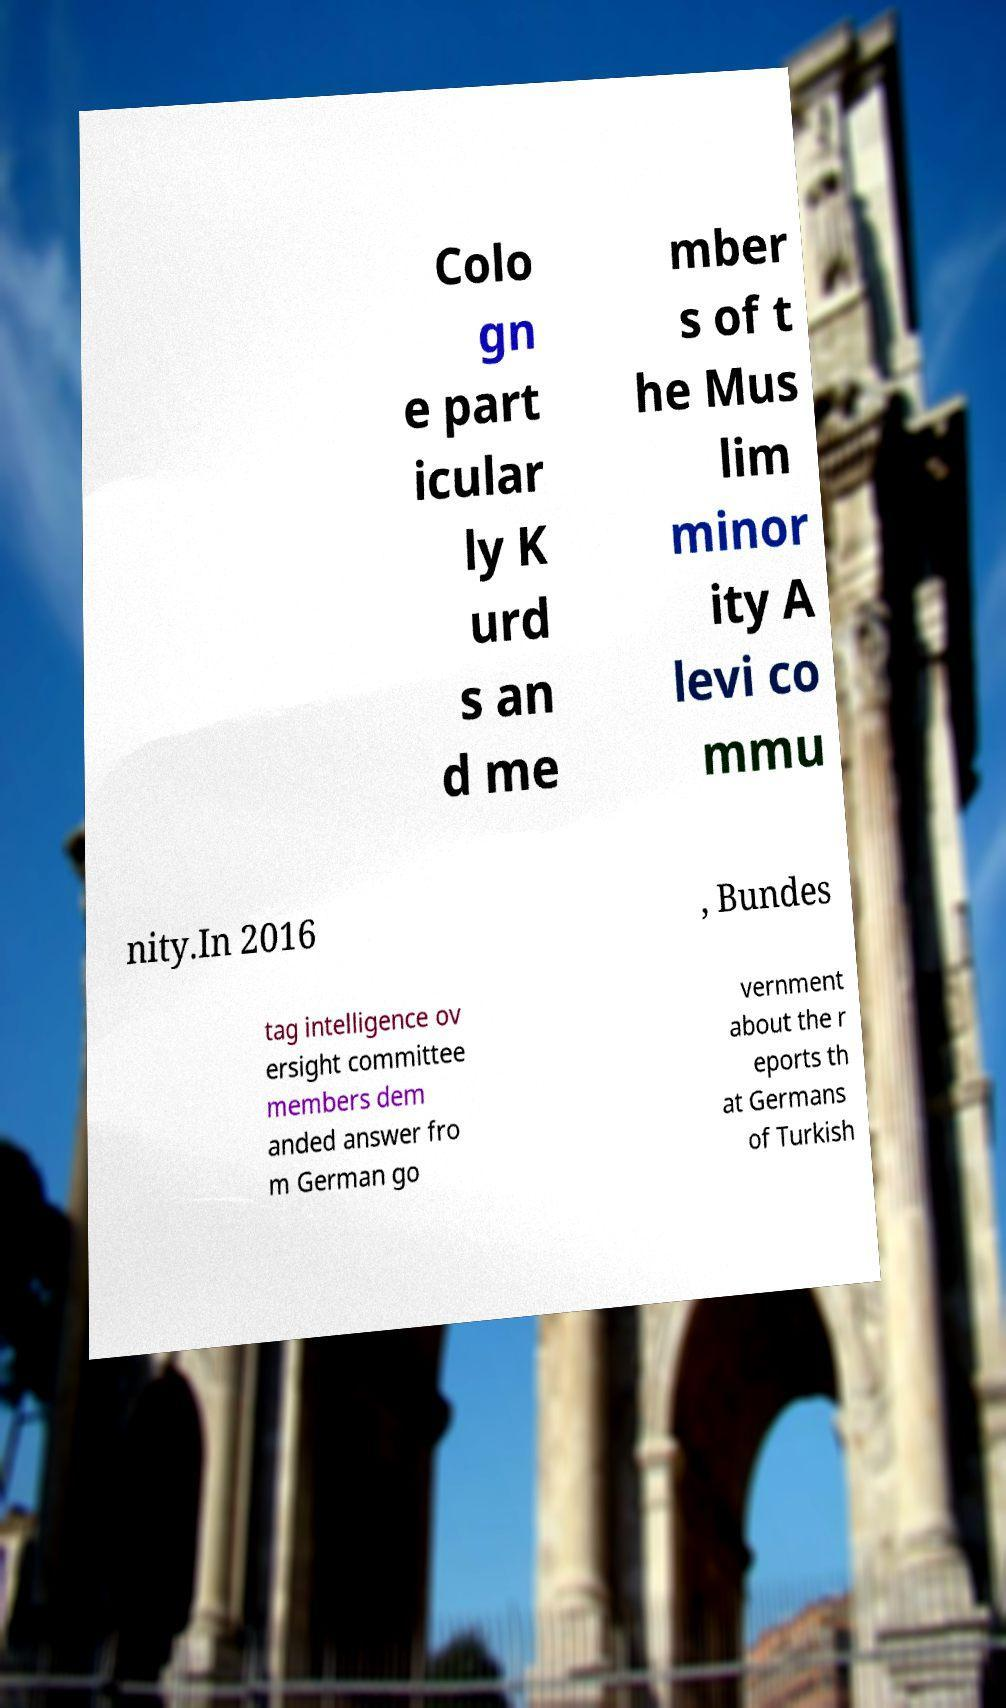Could you extract and type out the text from this image? Colo gn e part icular ly K urd s an d me mber s of t he Mus lim minor ity A levi co mmu nity.In 2016 , Bundes tag intelligence ov ersight committee members dem anded answer fro m German go vernment about the r eports th at Germans of Turkish 